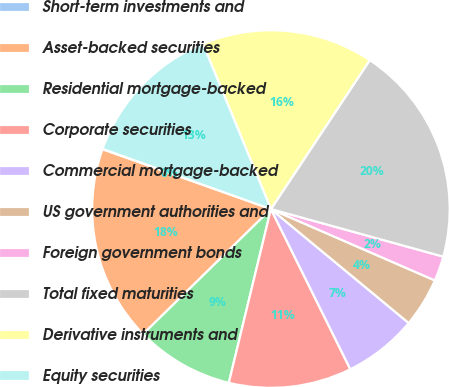Convert chart to OTSL. <chart><loc_0><loc_0><loc_500><loc_500><pie_chart><fcel>Short-term investments and<fcel>Asset-backed securities<fcel>Residential mortgage-backed<fcel>Corporate securities<fcel>Commercial mortgage-backed<fcel>US government authorities and<fcel>Foreign government bonds<fcel>Total fixed maturities<fcel>Derivative instruments and<fcel>Equity securities<nl><fcel>0.04%<fcel>17.75%<fcel>8.89%<fcel>11.11%<fcel>6.68%<fcel>4.46%<fcel>2.25%<fcel>19.96%<fcel>15.54%<fcel>13.32%<nl></chart> 